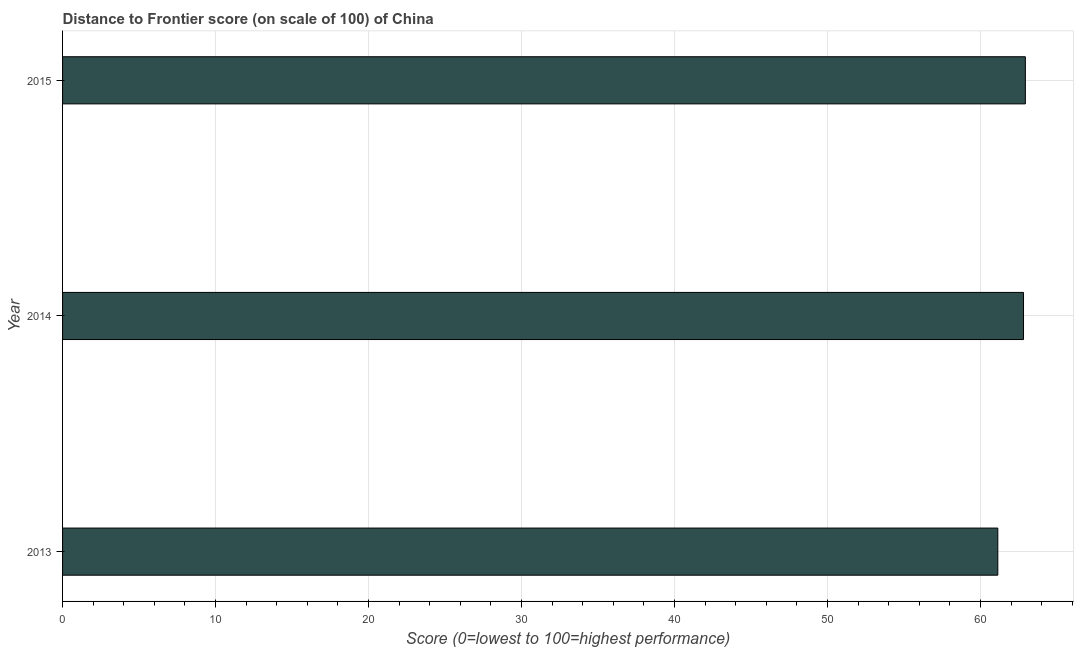What is the title of the graph?
Your response must be concise. Distance to Frontier score (on scale of 100) of China. What is the label or title of the X-axis?
Your response must be concise. Score (0=lowest to 100=highest performance). What is the label or title of the Y-axis?
Make the answer very short. Year. What is the distance to frontier score in 2015?
Offer a terse response. 62.93. Across all years, what is the maximum distance to frontier score?
Provide a succinct answer. 62.93. Across all years, what is the minimum distance to frontier score?
Ensure brevity in your answer.  61.13. In which year was the distance to frontier score maximum?
Your answer should be very brief. 2015. What is the sum of the distance to frontier score?
Make the answer very short. 186.87. What is the difference between the distance to frontier score in 2013 and 2015?
Offer a terse response. -1.8. What is the average distance to frontier score per year?
Provide a succinct answer. 62.29. What is the median distance to frontier score?
Make the answer very short. 62.81. In how many years, is the distance to frontier score greater than 50 ?
Your answer should be very brief. 3. Is the distance to frontier score in 2013 less than that in 2015?
Make the answer very short. Yes. What is the difference between the highest and the second highest distance to frontier score?
Provide a short and direct response. 0.12. Is the sum of the distance to frontier score in 2013 and 2015 greater than the maximum distance to frontier score across all years?
Keep it short and to the point. Yes. What is the difference between the highest and the lowest distance to frontier score?
Give a very brief answer. 1.8. What is the Score (0=lowest to 100=highest performance) in 2013?
Make the answer very short. 61.13. What is the Score (0=lowest to 100=highest performance) in 2014?
Ensure brevity in your answer.  62.81. What is the Score (0=lowest to 100=highest performance) in 2015?
Provide a short and direct response. 62.93. What is the difference between the Score (0=lowest to 100=highest performance) in 2013 and 2014?
Keep it short and to the point. -1.68. What is the difference between the Score (0=lowest to 100=highest performance) in 2014 and 2015?
Give a very brief answer. -0.12. What is the ratio of the Score (0=lowest to 100=highest performance) in 2013 to that in 2014?
Offer a terse response. 0.97. What is the ratio of the Score (0=lowest to 100=highest performance) in 2013 to that in 2015?
Offer a terse response. 0.97. What is the ratio of the Score (0=lowest to 100=highest performance) in 2014 to that in 2015?
Your answer should be very brief. 1. 